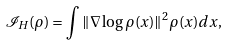Convert formula to latex. <formula><loc_0><loc_0><loc_500><loc_500>\mathcal { I } _ { H } ( \rho ) = \int \| \nabla \log \rho ( x ) \| ^ { 2 } \rho ( x ) d x ,</formula> 